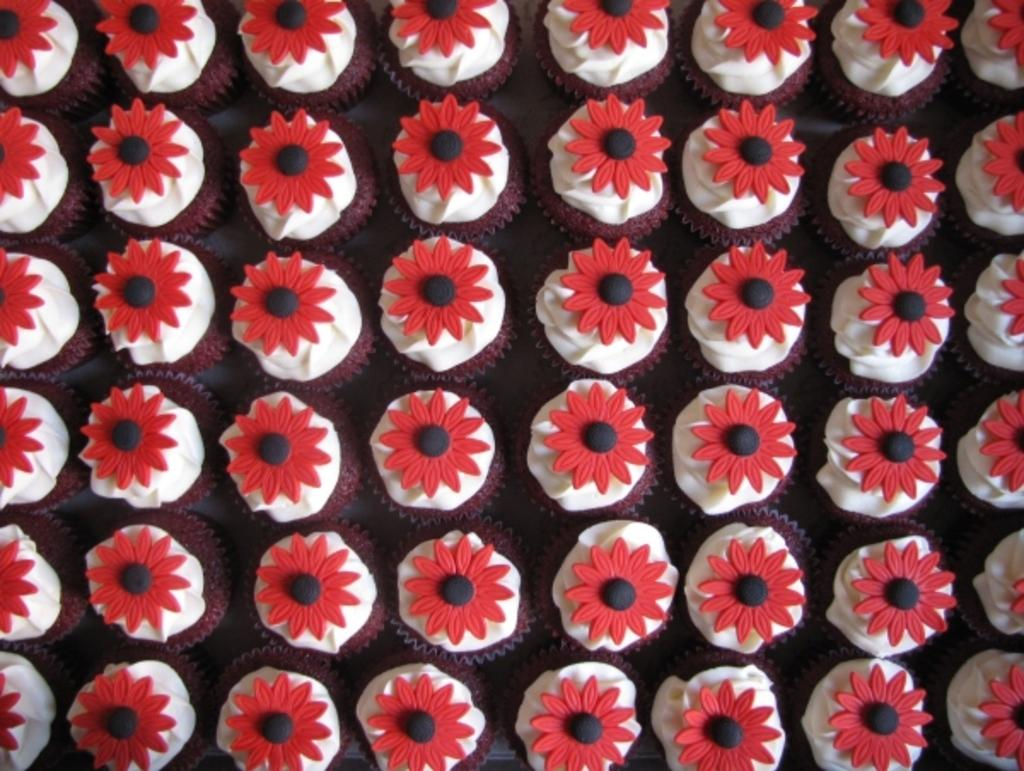What type of food is visible in the image? There are cupcakes in the image. Where are the cupcakes located? The cupcakes are placed on a surface. What organization is responsible for the production of the cupcakes in the image? There is no information about the organization responsible for the production of the cupcakes in the image. 